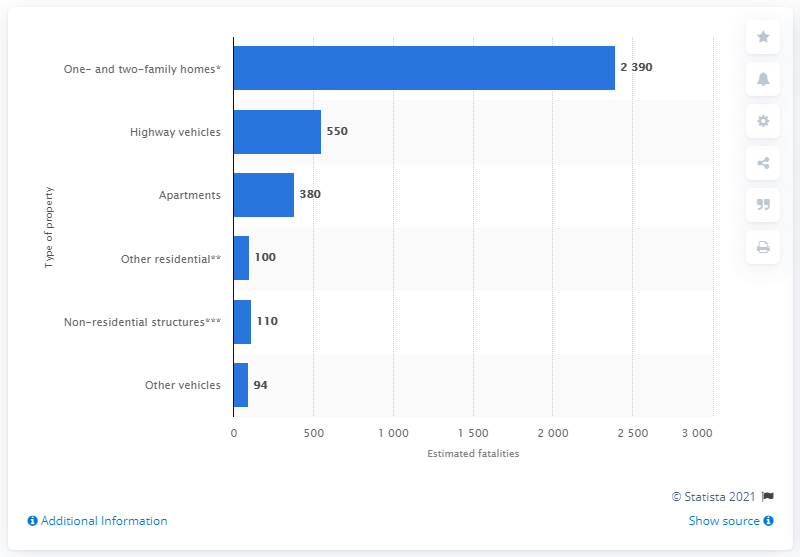Draw attention to some important aspects in this diagram. In 2019, a total of 380 civilians lost their lives in apartment fires across the country. 